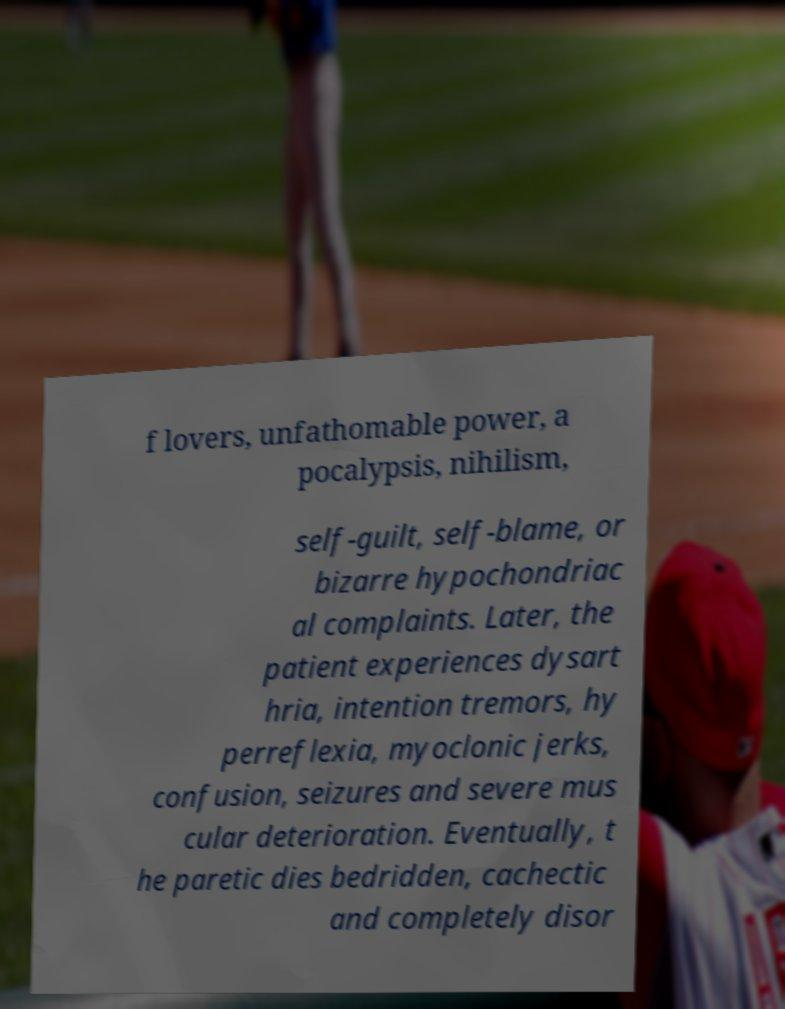Please read and relay the text visible in this image. What does it say? f lovers, unfathomable power, a pocalypsis, nihilism, self-guilt, self-blame, or bizarre hypochondriac al complaints. Later, the patient experiences dysart hria, intention tremors, hy perreflexia, myoclonic jerks, confusion, seizures and severe mus cular deterioration. Eventually, t he paretic dies bedridden, cachectic and completely disor 